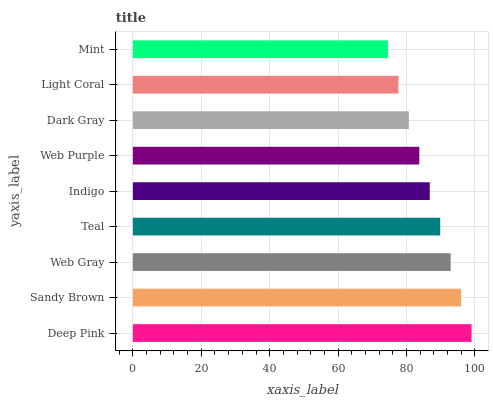Is Mint the minimum?
Answer yes or no. Yes. Is Deep Pink the maximum?
Answer yes or no. Yes. Is Sandy Brown the minimum?
Answer yes or no. No. Is Sandy Brown the maximum?
Answer yes or no. No. Is Deep Pink greater than Sandy Brown?
Answer yes or no. Yes. Is Sandy Brown less than Deep Pink?
Answer yes or no. Yes. Is Sandy Brown greater than Deep Pink?
Answer yes or no. No. Is Deep Pink less than Sandy Brown?
Answer yes or no. No. Is Indigo the high median?
Answer yes or no. Yes. Is Indigo the low median?
Answer yes or no. Yes. Is Web Purple the high median?
Answer yes or no. No. Is Mint the low median?
Answer yes or no. No. 